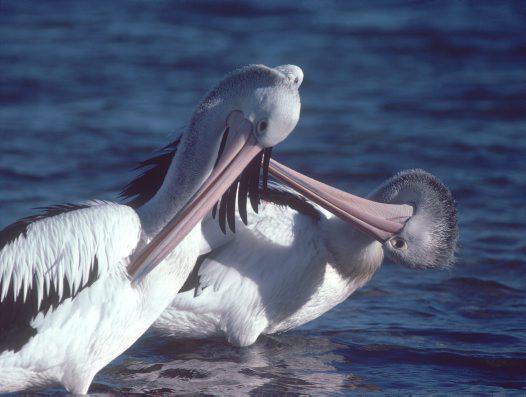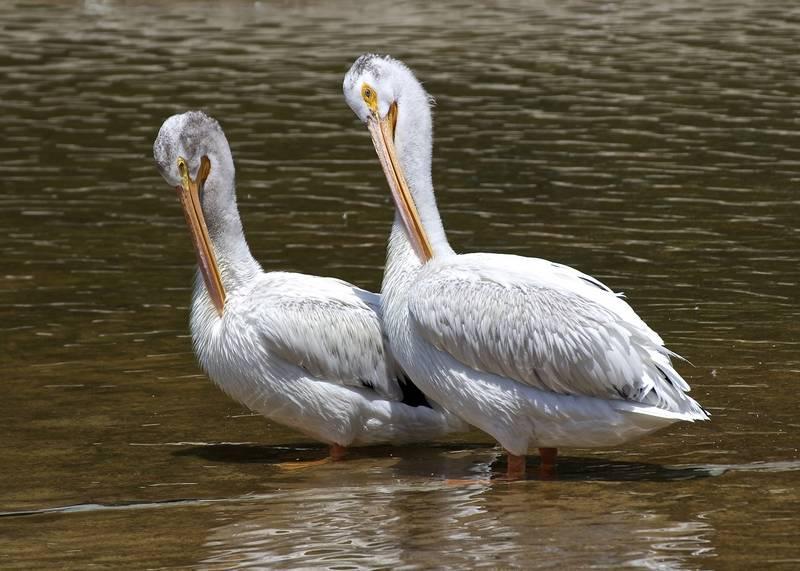The first image is the image on the left, the second image is the image on the right. Examine the images to the left and right. Is the description "there are no more then two birds in the left pic" accurate? Answer yes or no. Yes. The first image is the image on the left, the second image is the image on the right. Assess this claim about the two images: "There are at least six pelicans.". Correct or not? Answer yes or no. No. 